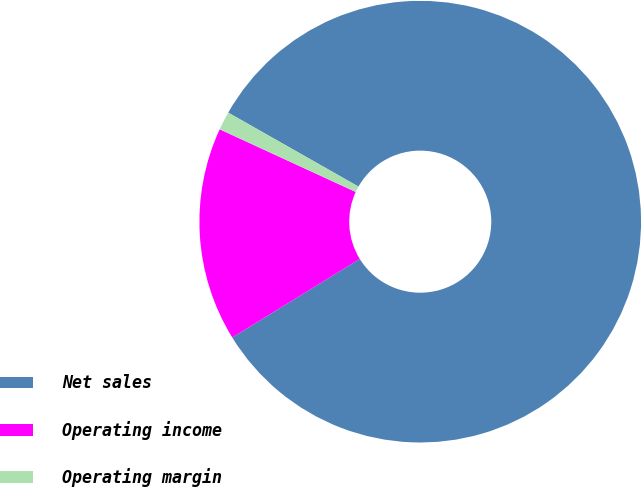Convert chart to OTSL. <chart><loc_0><loc_0><loc_500><loc_500><pie_chart><fcel>Net sales<fcel>Operating income<fcel>Operating margin<nl><fcel>82.99%<fcel>15.66%<fcel>1.35%<nl></chart> 